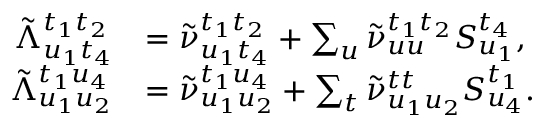<formula> <loc_0><loc_0><loc_500><loc_500>\begin{array} { r l } { \tilde { \Lambda } _ { u _ { 1 } t _ { 4 } } ^ { t _ { 1 } t _ { 2 } } } & { = \tilde { \nu } _ { u _ { 1 } t _ { 4 } } ^ { t _ { 1 } t _ { 2 } } + \sum _ { u } \tilde { \nu } _ { u u } ^ { t _ { 1 } t _ { 2 } } S _ { u _ { 1 } } ^ { t _ { 4 } } , } \\ { \tilde { \Lambda } _ { u _ { 1 } u _ { 2 } } ^ { t _ { 1 } u _ { 4 } } } & { = \tilde { \nu } _ { u _ { 1 } u _ { 2 } } ^ { t _ { 1 } u _ { 4 } } + \sum _ { t } \tilde { \nu } _ { u _ { 1 } u _ { 2 } } ^ { t t } S _ { u _ { 4 } } ^ { t _ { 1 } } . } \end{array}</formula> 